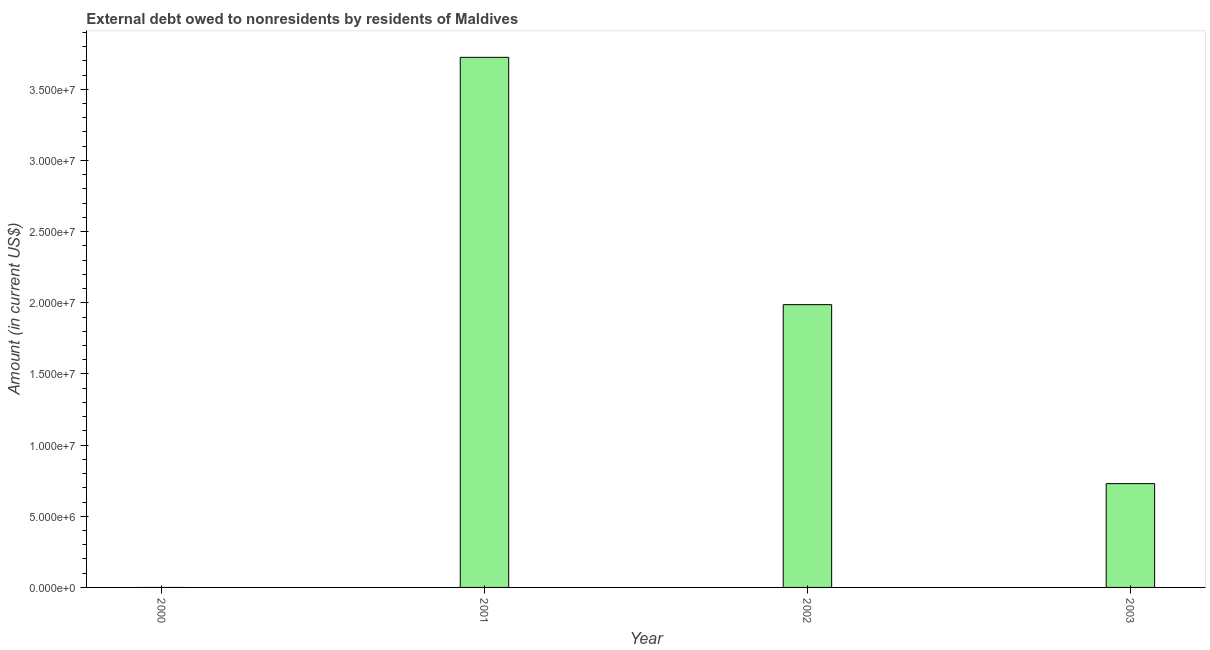What is the title of the graph?
Provide a succinct answer. External debt owed to nonresidents by residents of Maldives. What is the debt in 2003?
Offer a terse response. 7.29e+06. Across all years, what is the maximum debt?
Provide a succinct answer. 3.72e+07. In which year was the debt maximum?
Your answer should be very brief. 2001. What is the sum of the debt?
Your response must be concise. 6.44e+07. What is the difference between the debt in 2002 and 2003?
Keep it short and to the point. 1.26e+07. What is the average debt per year?
Your answer should be compact. 1.61e+07. What is the median debt?
Provide a short and direct response. 1.36e+07. In how many years, is the debt greater than 12000000 US$?
Your answer should be very brief. 2. What is the ratio of the debt in 2001 to that in 2002?
Give a very brief answer. 1.88. Is the debt in 2001 less than that in 2003?
Your answer should be compact. No. What is the difference between the highest and the second highest debt?
Your answer should be compact. 1.74e+07. What is the difference between the highest and the lowest debt?
Offer a very short reply. 3.72e+07. In how many years, is the debt greater than the average debt taken over all years?
Make the answer very short. 2. How many bars are there?
Your answer should be very brief. 3. Are all the bars in the graph horizontal?
Offer a terse response. No. How many years are there in the graph?
Your response must be concise. 4. What is the difference between two consecutive major ticks on the Y-axis?
Offer a terse response. 5.00e+06. Are the values on the major ticks of Y-axis written in scientific E-notation?
Your answer should be compact. Yes. What is the Amount (in current US$) in 2000?
Keep it short and to the point. 0. What is the Amount (in current US$) of 2001?
Offer a terse response. 3.72e+07. What is the Amount (in current US$) in 2002?
Ensure brevity in your answer.  1.99e+07. What is the Amount (in current US$) of 2003?
Offer a terse response. 7.29e+06. What is the difference between the Amount (in current US$) in 2001 and 2002?
Your response must be concise. 1.74e+07. What is the difference between the Amount (in current US$) in 2001 and 2003?
Keep it short and to the point. 3.00e+07. What is the difference between the Amount (in current US$) in 2002 and 2003?
Keep it short and to the point. 1.26e+07. What is the ratio of the Amount (in current US$) in 2001 to that in 2002?
Offer a terse response. 1.88. What is the ratio of the Amount (in current US$) in 2001 to that in 2003?
Your response must be concise. 5.11. What is the ratio of the Amount (in current US$) in 2002 to that in 2003?
Give a very brief answer. 2.72. 